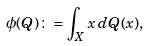<formula> <loc_0><loc_0><loc_500><loc_500>\phi ( Q ) \colon = \int _ { X } x \, d Q ( x ) ,</formula> 